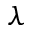<formula> <loc_0><loc_0><loc_500><loc_500>\lambda</formula> 